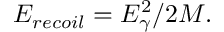Convert formula to latex. <formula><loc_0><loc_0><loc_500><loc_500>E _ { r e c o i l } = E _ { \gamma } ^ { 2 } / 2 M .</formula> 